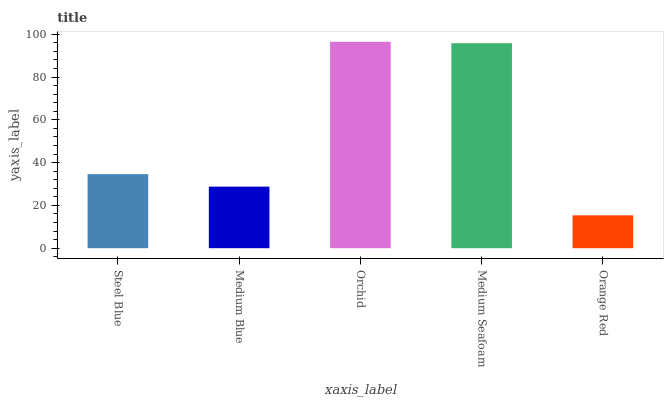Is Orange Red the minimum?
Answer yes or no. Yes. Is Orchid the maximum?
Answer yes or no. Yes. Is Medium Blue the minimum?
Answer yes or no. No. Is Medium Blue the maximum?
Answer yes or no. No. Is Steel Blue greater than Medium Blue?
Answer yes or no. Yes. Is Medium Blue less than Steel Blue?
Answer yes or no. Yes. Is Medium Blue greater than Steel Blue?
Answer yes or no. No. Is Steel Blue less than Medium Blue?
Answer yes or no. No. Is Steel Blue the high median?
Answer yes or no. Yes. Is Steel Blue the low median?
Answer yes or no. Yes. Is Medium Blue the high median?
Answer yes or no. No. Is Medium Seafoam the low median?
Answer yes or no. No. 